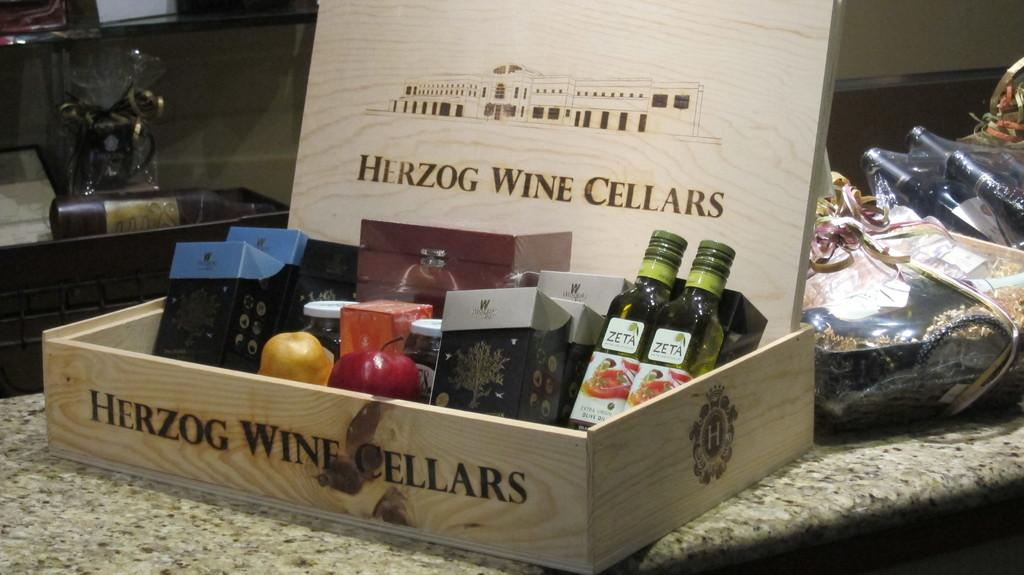Provide a one-sentence caption for the provided image. An assorted gifts in a wooden box, stamped Herzog Wine Cellars. 